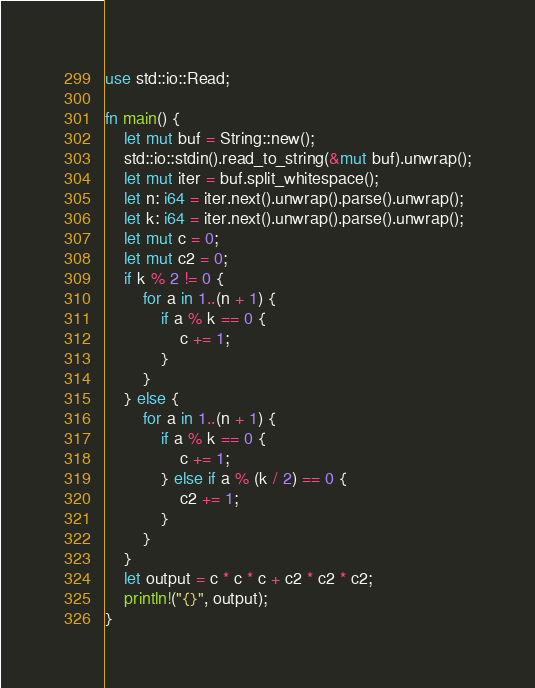<code> <loc_0><loc_0><loc_500><loc_500><_Rust_>use std::io::Read;

fn main() {
    let mut buf = String::new();
    std::io::stdin().read_to_string(&mut buf).unwrap();
    let mut iter = buf.split_whitespace();
    let n: i64 = iter.next().unwrap().parse().unwrap();
    let k: i64 = iter.next().unwrap().parse().unwrap();
    let mut c = 0;
    let mut c2 = 0;
    if k % 2 != 0 {
        for a in 1..(n + 1) {
            if a % k == 0 {
                c += 1;
            }
        }
    } else {
        for a in 1..(n + 1) {
            if a % k == 0 {
                c += 1;
            } else if a % (k / 2) == 0 {
                c2 += 1;
            }
        }
    }
    let output = c * c * c + c2 * c2 * c2;
    println!("{}", output);
}
</code> 